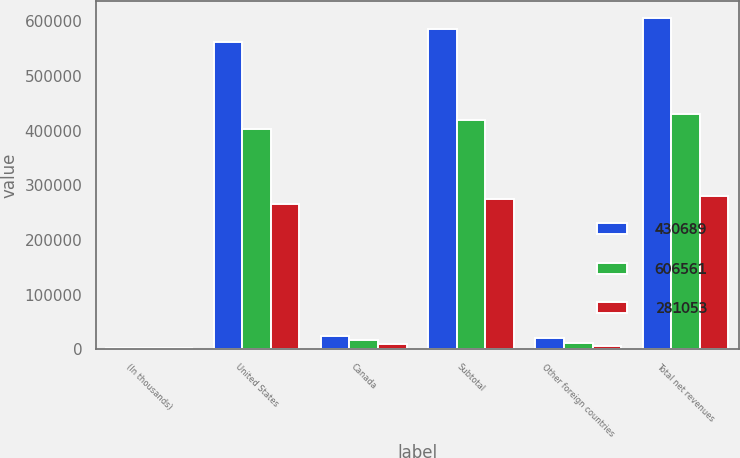Convert chart to OTSL. <chart><loc_0><loc_0><loc_500><loc_500><stacked_bar_chart><ecel><fcel>(In thousands)<fcel>United States<fcel>Canada<fcel>Subtotal<fcel>Other foreign countries<fcel>Total net revenues<nl><fcel>430689<fcel>2007<fcel>562439<fcel>23360<fcel>585799<fcel>20762<fcel>606561<nl><fcel>606561<fcel>2006<fcel>403725<fcel>16485<fcel>420210<fcel>10479<fcel>430689<nl><fcel>281053<fcel>2005<fcel>266048<fcel>9502<fcel>275550<fcel>5503<fcel>281053<nl></chart> 